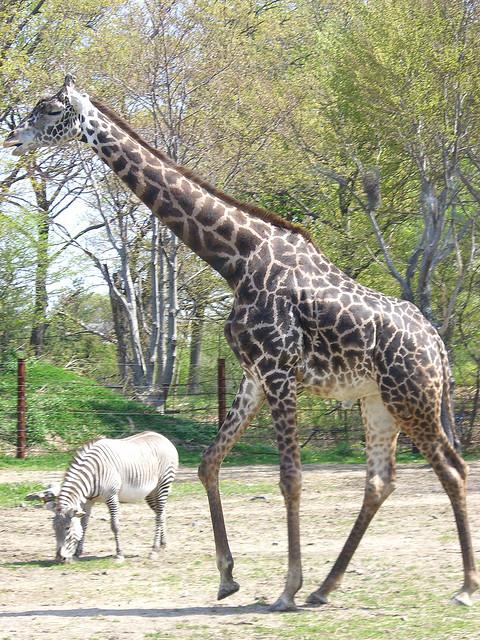Is this a winter scene?
Keep it brief. No. Which animal is taller?
Concise answer only. Giraffe. Does the zebra have tail?
Short answer required. Yes. 